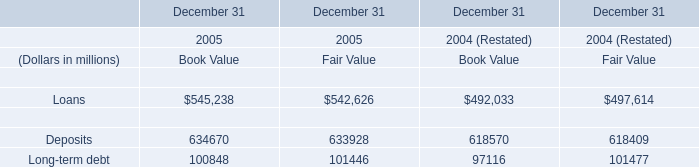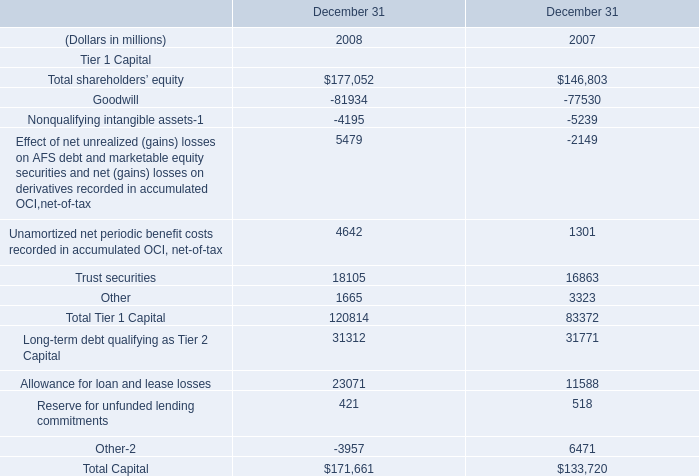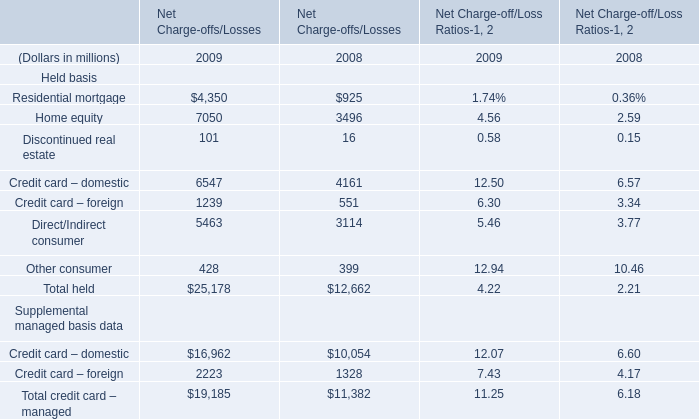In the year with largest amount of Residential mortgage, what's the increasing rate of Total held? 
Computations: ((25178 - 12662) / 25178)
Answer: 0.4971. 